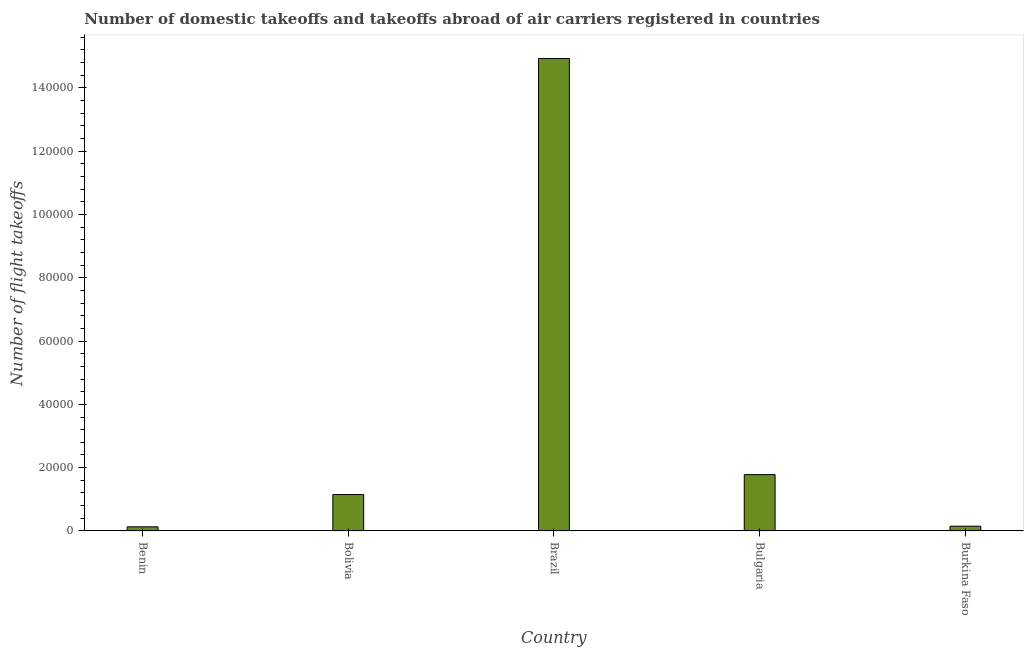What is the title of the graph?
Make the answer very short. Number of domestic takeoffs and takeoffs abroad of air carriers registered in countries. What is the label or title of the X-axis?
Provide a succinct answer. Country. What is the label or title of the Y-axis?
Keep it short and to the point. Number of flight takeoffs. What is the number of flight takeoffs in Burkina Faso?
Your answer should be compact. 1500. Across all countries, what is the maximum number of flight takeoffs?
Offer a very short reply. 1.49e+05. Across all countries, what is the minimum number of flight takeoffs?
Your answer should be very brief. 1300. In which country was the number of flight takeoffs minimum?
Give a very brief answer. Benin. What is the sum of the number of flight takeoffs?
Your answer should be very brief. 1.81e+05. What is the difference between the number of flight takeoffs in Bolivia and Burkina Faso?
Ensure brevity in your answer.  10000. What is the average number of flight takeoffs per country?
Offer a very short reply. 3.63e+04. What is the median number of flight takeoffs?
Ensure brevity in your answer.  1.15e+04. What is the ratio of the number of flight takeoffs in Benin to that in Burkina Faso?
Your response must be concise. 0.87. Is the difference between the number of flight takeoffs in Bulgaria and Burkina Faso greater than the difference between any two countries?
Your response must be concise. No. What is the difference between the highest and the second highest number of flight takeoffs?
Make the answer very short. 1.32e+05. Is the sum of the number of flight takeoffs in Bulgaria and Burkina Faso greater than the maximum number of flight takeoffs across all countries?
Ensure brevity in your answer.  No. What is the difference between the highest and the lowest number of flight takeoffs?
Offer a very short reply. 1.48e+05. In how many countries, is the number of flight takeoffs greater than the average number of flight takeoffs taken over all countries?
Provide a succinct answer. 1. Are all the bars in the graph horizontal?
Give a very brief answer. No. What is the difference between two consecutive major ticks on the Y-axis?
Give a very brief answer. 2.00e+04. What is the Number of flight takeoffs in Benin?
Your answer should be very brief. 1300. What is the Number of flight takeoffs in Bolivia?
Your answer should be compact. 1.15e+04. What is the Number of flight takeoffs of Brazil?
Your response must be concise. 1.49e+05. What is the Number of flight takeoffs of Bulgaria?
Your answer should be very brief. 1.78e+04. What is the Number of flight takeoffs of Burkina Faso?
Provide a short and direct response. 1500. What is the difference between the Number of flight takeoffs in Benin and Bolivia?
Your answer should be very brief. -1.02e+04. What is the difference between the Number of flight takeoffs in Benin and Brazil?
Your answer should be compact. -1.48e+05. What is the difference between the Number of flight takeoffs in Benin and Bulgaria?
Keep it short and to the point. -1.65e+04. What is the difference between the Number of flight takeoffs in Benin and Burkina Faso?
Make the answer very short. -200. What is the difference between the Number of flight takeoffs in Bolivia and Brazil?
Provide a succinct answer. -1.38e+05. What is the difference between the Number of flight takeoffs in Bolivia and Bulgaria?
Your response must be concise. -6300. What is the difference between the Number of flight takeoffs in Bolivia and Burkina Faso?
Ensure brevity in your answer.  10000. What is the difference between the Number of flight takeoffs in Brazil and Bulgaria?
Make the answer very short. 1.32e+05. What is the difference between the Number of flight takeoffs in Brazil and Burkina Faso?
Give a very brief answer. 1.48e+05. What is the difference between the Number of flight takeoffs in Bulgaria and Burkina Faso?
Give a very brief answer. 1.63e+04. What is the ratio of the Number of flight takeoffs in Benin to that in Bolivia?
Your response must be concise. 0.11. What is the ratio of the Number of flight takeoffs in Benin to that in Brazil?
Give a very brief answer. 0.01. What is the ratio of the Number of flight takeoffs in Benin to that in Bulgaria?
Offer a terse response. 0.07. What is the ratio of the Number of flight takeoffs in Benin to that in Burkina Faso?
Offer a very short reply. 0.87. What is the ratio of the Number of flight takeoffs in Bolivia to that in Brazil?
Give a very brief answer. 0.08. What is the ratio of the Number of flight takeoffs in Bolivia to that in Bulgaria?
Offer a terse response. 0.65. What is the ratio of the Number of flight takeoffs in Bolivia to that in Burkina Faso?
Offer a terse response. 7.67. What is the ratio of the Number of flight takeoffs in Brazil to that in Bulgaria?
Keep it short and to the point. 8.39. What is the ratio of the Number of flight takeoffs in Brazil to that in Burkina Faso?
Provide a short and direct response. 99.53. What is the ratio of the Number of flight takeoffs in Bulgaria to that in Burkina Faso?
Make the answer very short. 11.87. 